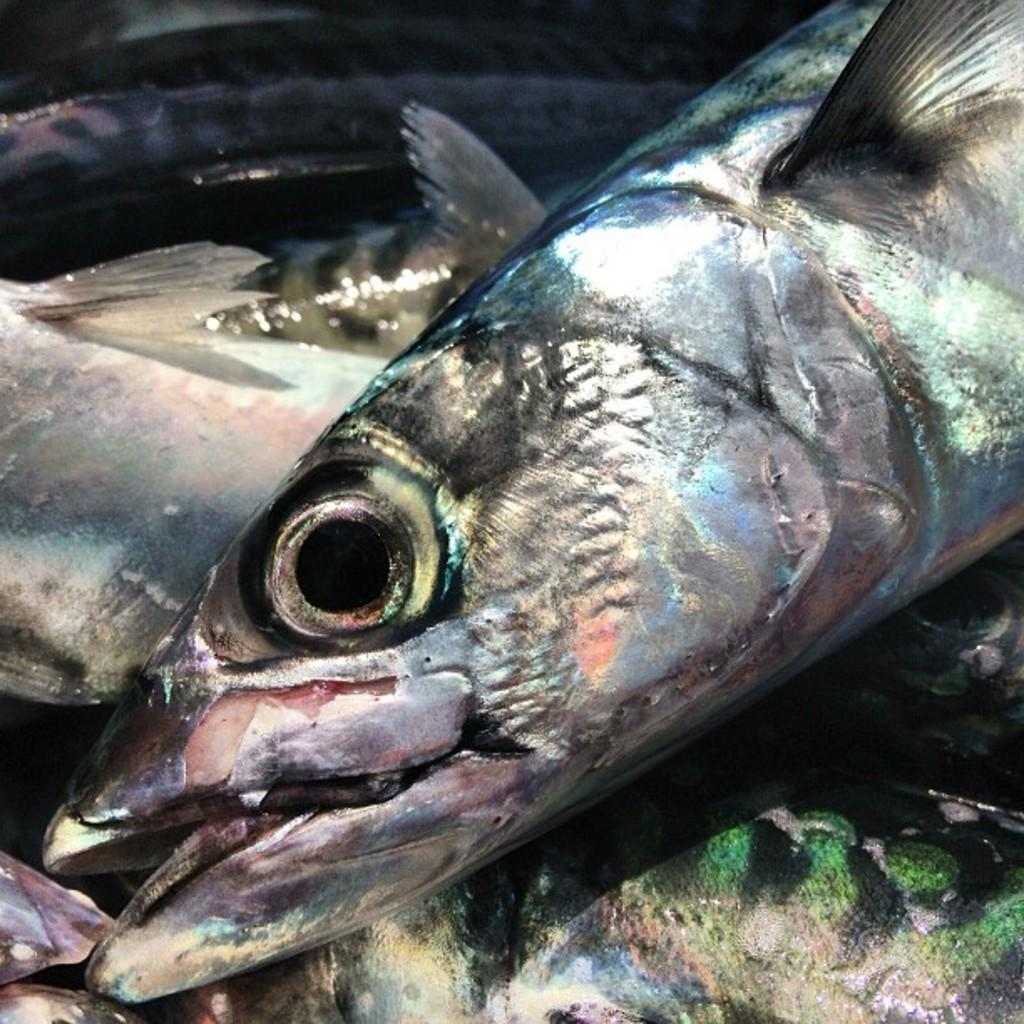What type of animals are present in the image? There is a group of fish in the image. What type of lamp can be seen illuminating the fish in the image? There is no lamp present in the image; it only features a group of fish. 